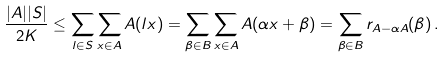Convert formula to latex. <formula><loc_0><loc_0><loc_500><loc_500>\frac { | A | | S | } { 2 K } \leq \sum _ { l \in S } \sum _ { x \in A } A ( l x ) = \sum _ { \beta \in B } \sum _ { x \in A } A ( \alpha x + \beta ) = \sum _ { \beta \in B } r _ { A - \alpha A } ( \beta ) \, .</formula> 